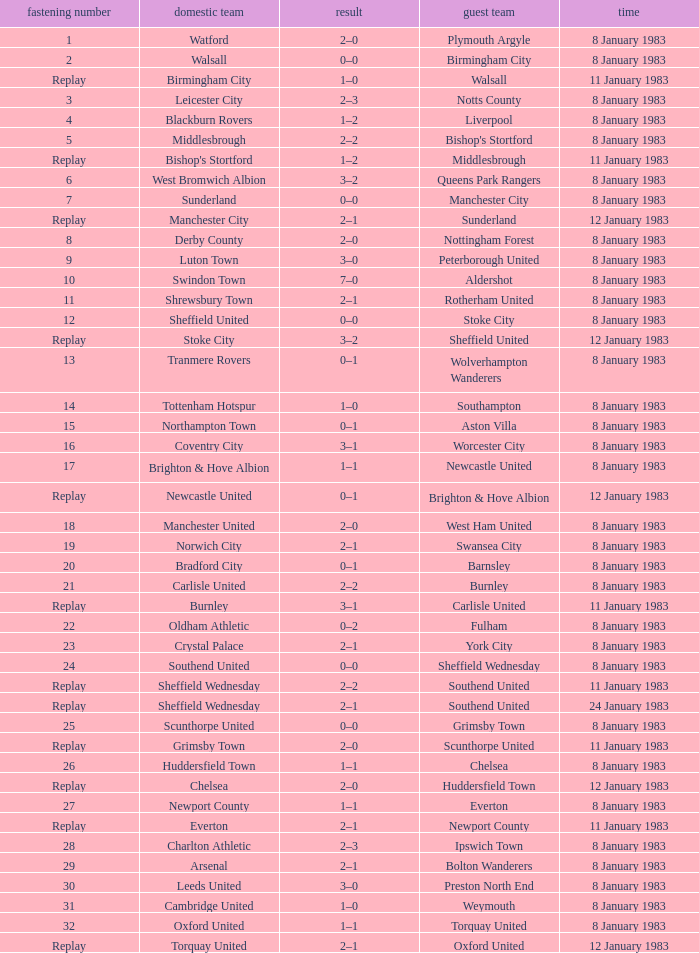What is the name of the away team for Tie #19? Swansea City. 